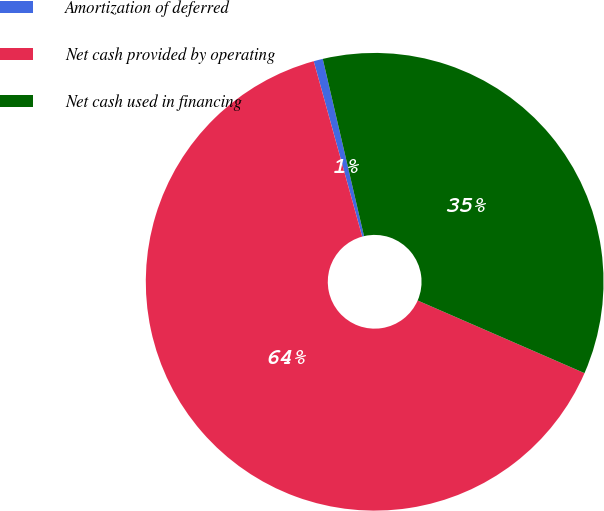Convert chart to OTSL. <chart><loc_0><loc_0><loc_500><loc_500><pie_chart><fcel>Amortization of deferred<fcel>Net cash provided by operating<fcel>Net cash used in financing<nl><fcel>0.65%<fcel>64.18%<fcel>35.18%<nl></chart> 